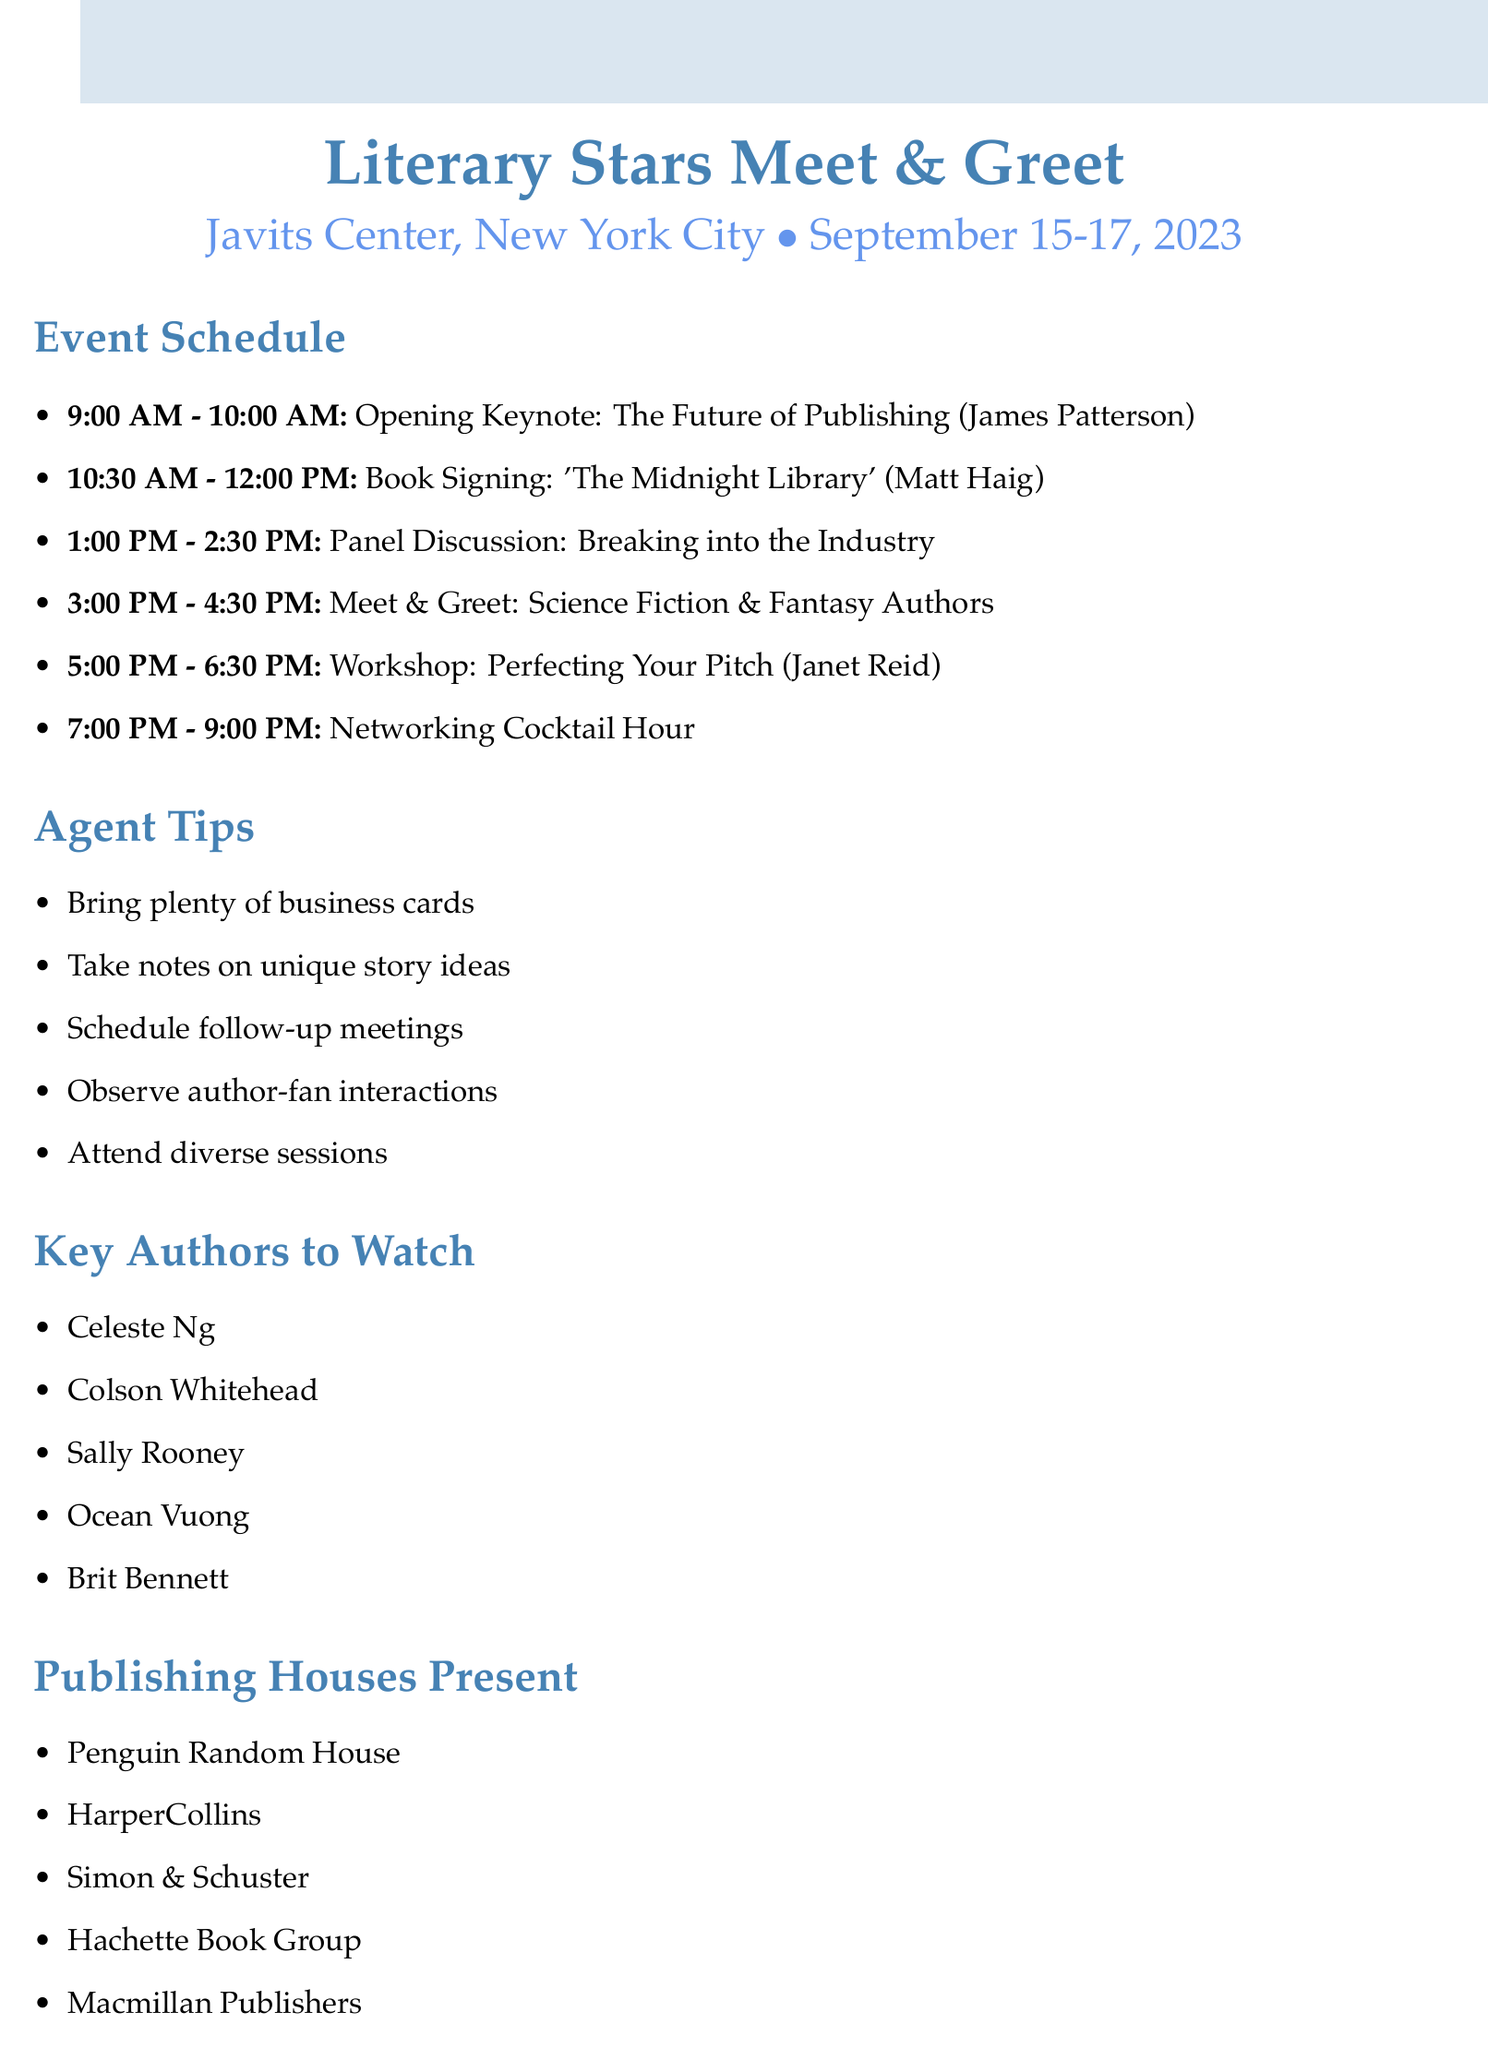What is the event title? The event title is explicitly stated at the beginning of the document.
Answer: Literary Stars Meet & Greet Who is the keynote speaker? The keynote speaker is mentioned in the schedule section of the document.
Answer: James Patterson What time does the book signing with Matt Haig start? The start time of the book signing is clearly listed in the schedule for that event.
Answer: 10:30 AM How long is the workshop hosted by Janet Reid? The duration of the workshop is derived from the start and end times provided in the schedule.
Answer: 1.5 hours Which publishing house is listed last in the document? The last publishing house is the final item in the publishing houses present section.
Answer: Macmillan Publishers Which session allows interaction with Science Fiction and Fantasy authors? The session title for interaction with these authors is found in the event schedule.
Answer: Meet & Greet: Science Fiction & Fantasy Authors What is the focus of the 'Perfecting Your Pitch' workshop? The workshop's focus is described in the session description, which details its purpose.
Answer: Craft compelling pitches How many authors are highlighted in the "Key Authors to Watch"? The number of authors is counted from the list provided in that section.
Answer: 5 What is the date range for the event? The date range is provided at the top of the document under the event information.
Answer: September 15-17, 2023 